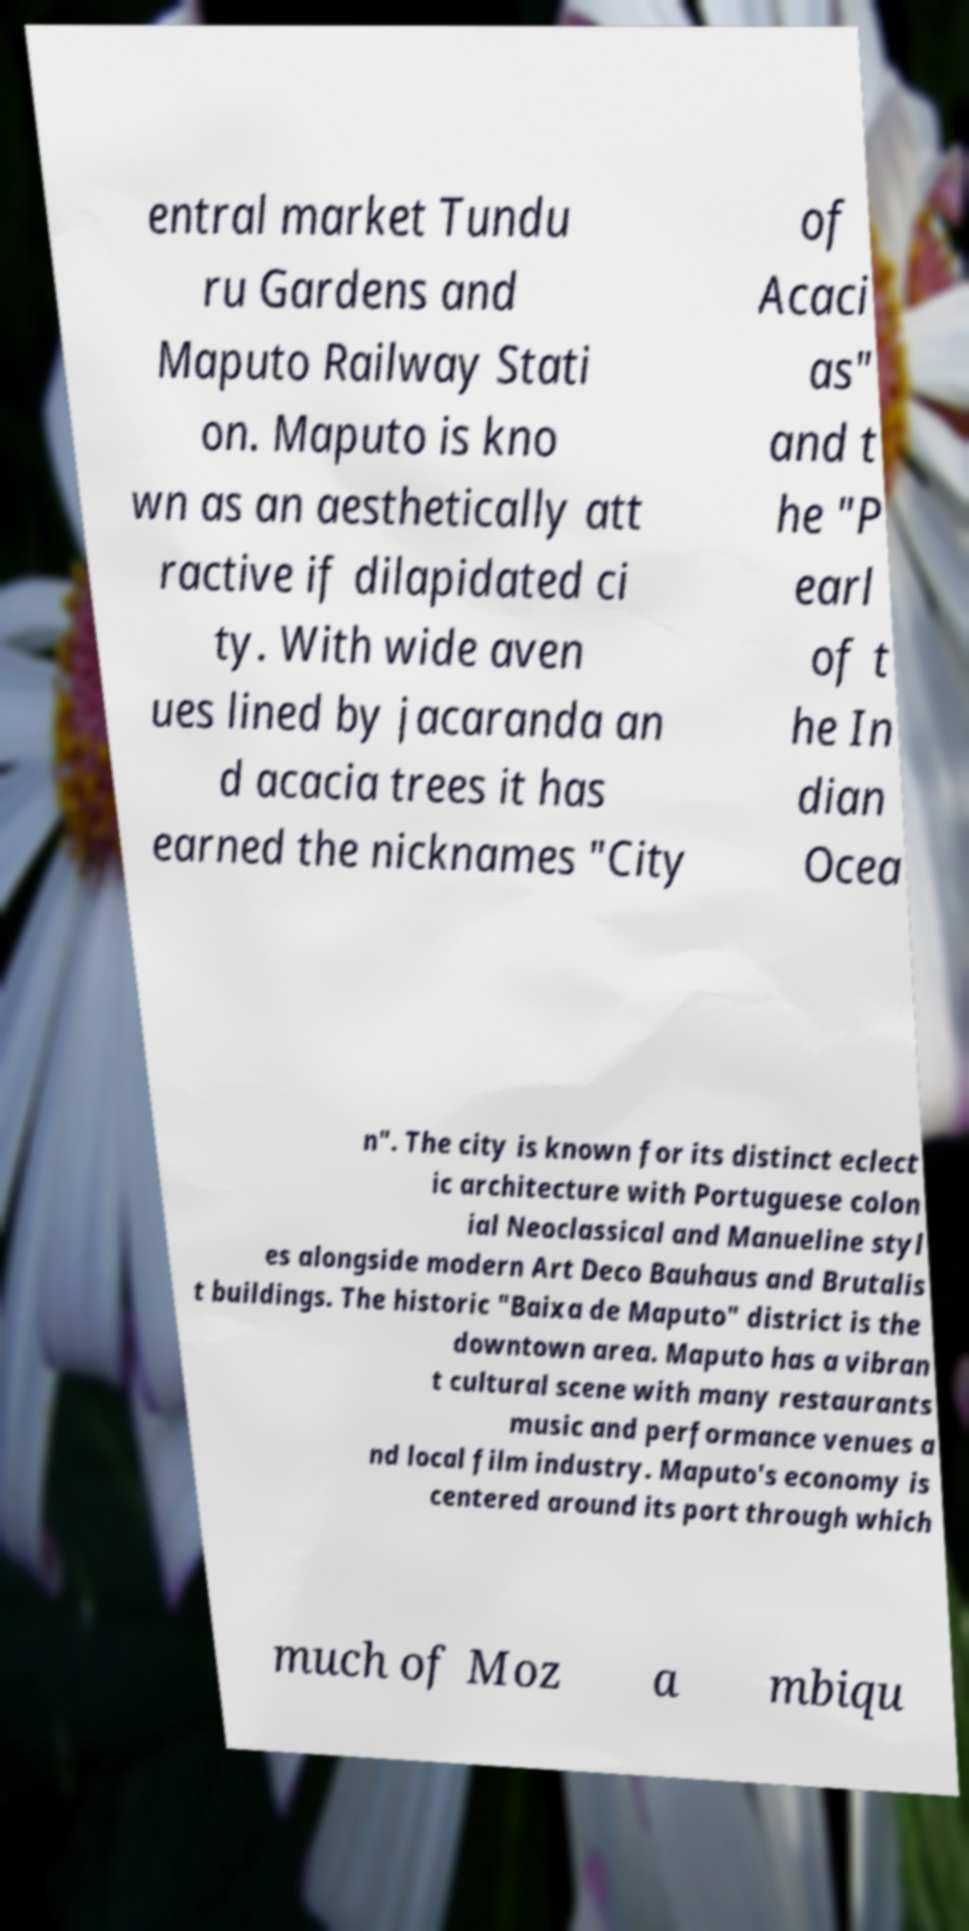Please identify and transcribe the text found in this image. entral market Tundu ru Gardens and Maputo Railway Stati on. Maputo is kno wn as an aesthetically att ractive if dilapidated ci ty. With wide aven ues lined by jacaranda an d acacia trees it has earned the nicknames "City of Acaci as" and t he "P earl of t he In dian Ocea n". The city is known for its distinct eclect ic architecture with Portuguese colon ial Neoclassical and Manueline styl es alongside modern Art Deco Bauhaus and Brutalis t buildings. The historic "Baixa de Maputo" district is the downtown area. Maputo has a vibran t cultural scene with many restaurants music and performance venues a nd local film industry. Maputo's economy is centered around its port through which much of Moz a mbiqu 